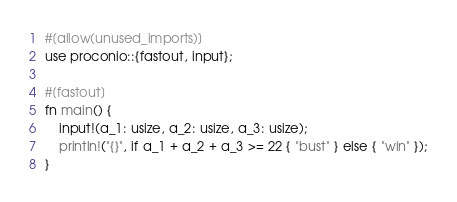Convert code to text. <code><loc_0><loc_0><loc_500><loc_500><_Rust_>#[allow(unused_imports)]
use proconio::{fastout, input};

#[fastout]
fn main() {
    input!(a_1: usize, a_2: usize, a_3: usize);
    println!("{}", if a_1 + a_2 + a_3 >= 22 { "bust" } else { "win" });
}
</code> 